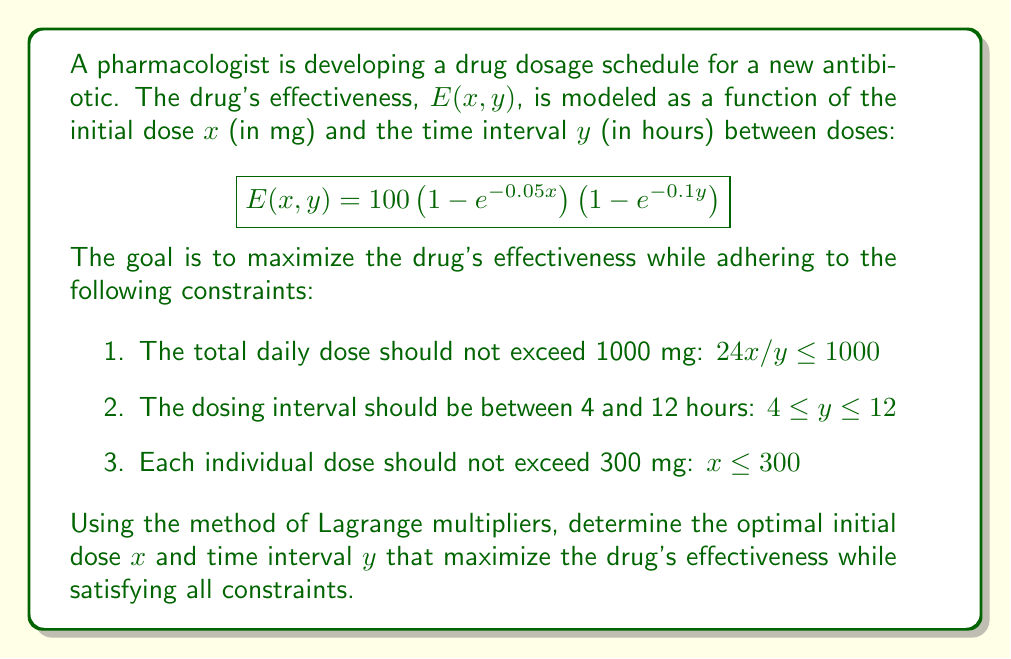Can you answer this question? To solve this constrained optimization problem, we'll use the method of Lagrange multipliers. Here's a step-by-step approach:

1) First, we need to identify the active constraints. Given the nature of the problem, we can assume that the total daily dose constraint will be active:

   $$g(x,y) = 24x/y - 1000 = 0$$

2) We'll form the Lagrangian function with this constraint:

   $$L(x,y,\lambda) = 100\left(1 - e^{-0.05x}\right)\left(1 - e^{-0.1y}\right) - \lambda(24x/y - 1000)$$

3) Now, we'll set up the system of equations by taking partial derivatives and setting them to zero:

   $$\frac{\partial L}{\partial x} = 5e^{-0.05x}\left(1 - e^{-0.1y}\right) - 24\lambda/y = 0$$
   
   $$\frac{\partial L}{\partial y} = 10e^{-0.1y}\left(1 - e^{-0.05x}\right) + 24\lambda x/y^2 = 0$$
   
   $$\frac{\partial L}{\partial \lambda} = 24x/y - 1000 = 0$$

4) From the last equation, we can express $x$ in terms of $y$:

   $$x = 1000y/24$$

5) Substituting this into the first two equations:

   $$5e^{-0.05(1000y/24)}\left(1 - e^{-0.1y}\right) - 24\lambda/y = 0$$
   
   $$10e^{-0.1y}\left(1 - e^{-0.05(1000y/24)}\right) + \lambda/y = 0$$

6) Dividing the first equation by 5 and the second by 10:

   $$e^{-0.05(1000y/24)}\left(1 - e^{-0.1y}\right) - 4.8\lambda/y = 0$$
   
   $$e^{-0.1y}\left(1 - e^{-0.05(1000y/24)}\right) + 0.1\lambda/y = 0$$

7) Adding these equations eliminates $\lambda$:

   $$e^{-0.05(1000y/24)}\left(1 - e^{-0.1y}\right) + e^{-0.1y}\left(1 - e^{-0.05(1000y/24)}\right) = 0$$

8) This equation can be solved numerically to find $y \approx 8.28$ hours.

9) Using this value of $y$, we can calculate $x$:

   $$x = 1000(8.28)/24 \approx 345$$ mg

10) However, this violates the constraint $x \leq 300$. Therefore, we need to set $x = 300$ mg and recalculate $y$:

    $$y = 24(300)/1000 = 7.2$$ hours

11) We need to verify that this solution satisfies all constraints:
    - Total daily dose: $24(300)/7.2 = 1000$ mg (satisfies $\leq 1000$ mg)
    - Dosing interval: $7.2$ hours (satisfies $4 \leq y \leq 12$)
    - Individual dose: $300$ mg (satisfies $x \leq 300$)

Therefore, the optimal solution that satisfies all constraints is $x = 300$ mg and $y = 7.2$ hours.
Answer: The optimal dosage schedule is an initial dose of $x = 300$ mg every $y = 7.2$ hours. 